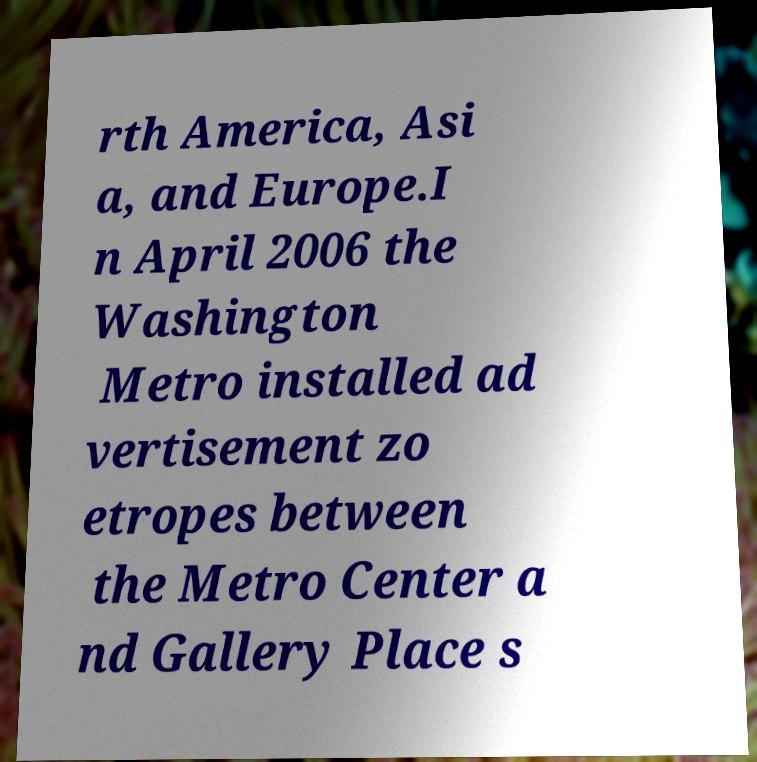Could you extract and type out the text from this image? rth America, Asi a, and Europe.I n April 2006 the Washington Metro installed ad vertisement zo etropes between the Metro Center a nd Gallery Place s 